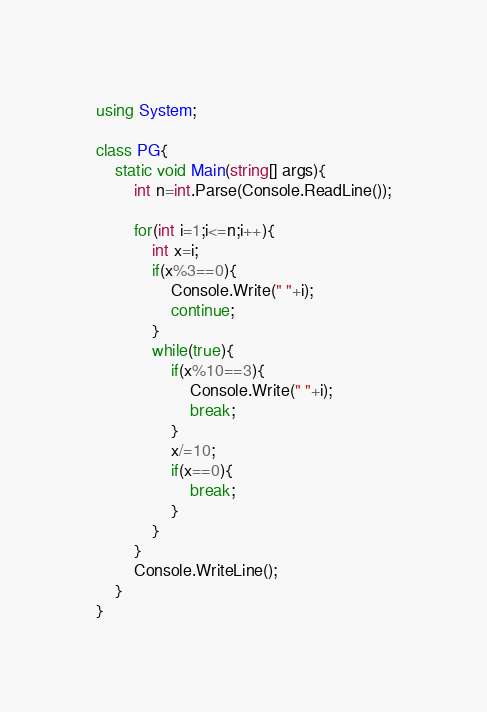<code> <loc_0><loc_0><loc_500><loc_500><_C#_>using System;

class PG{
    static void Main(string[] args){
        int n=int.Parse(Console.ReadLine());
        
        for(int i=1;i<=n;i++){
            int x=i;
            if(x%3==0){
                Console.Write(" "+i);
                continue;
            }
            while(true){
                if(x%10==3){
                    Console.Write(" "+i);
                    break;
                }
                x/=10;
                if(x==0){
                    break;
                }
            }
        }
        Console.WriteLine();
    }
}
</code> 